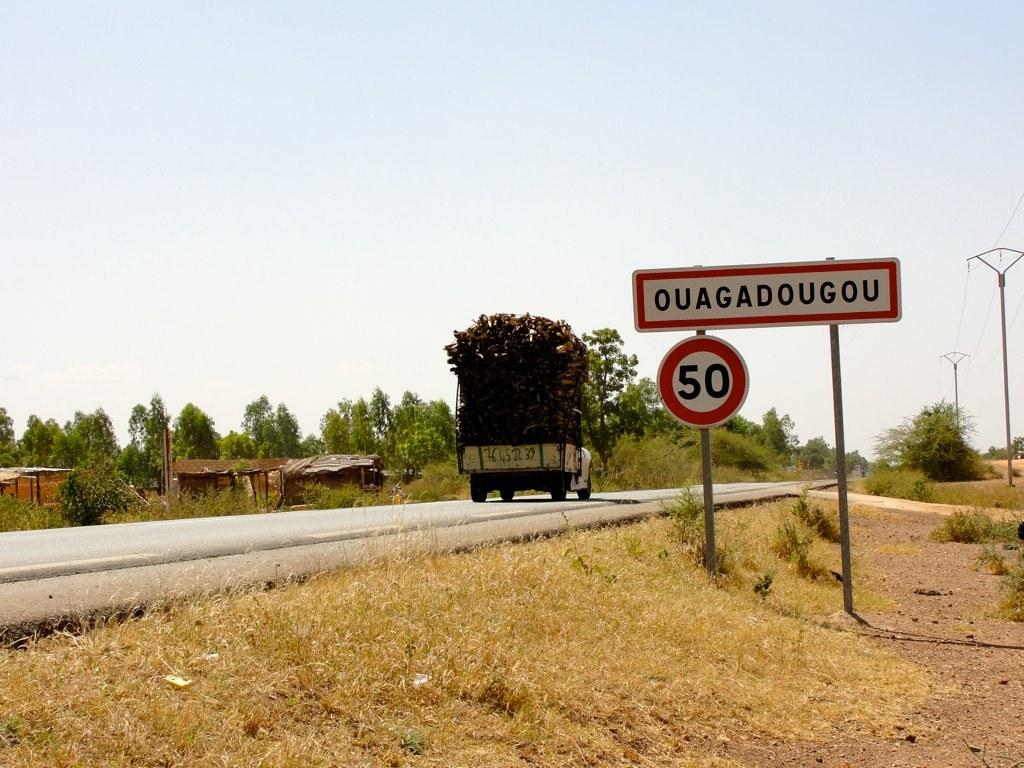<image>
Describe the image concisely. a street with a sign for Ouagadougou 50 